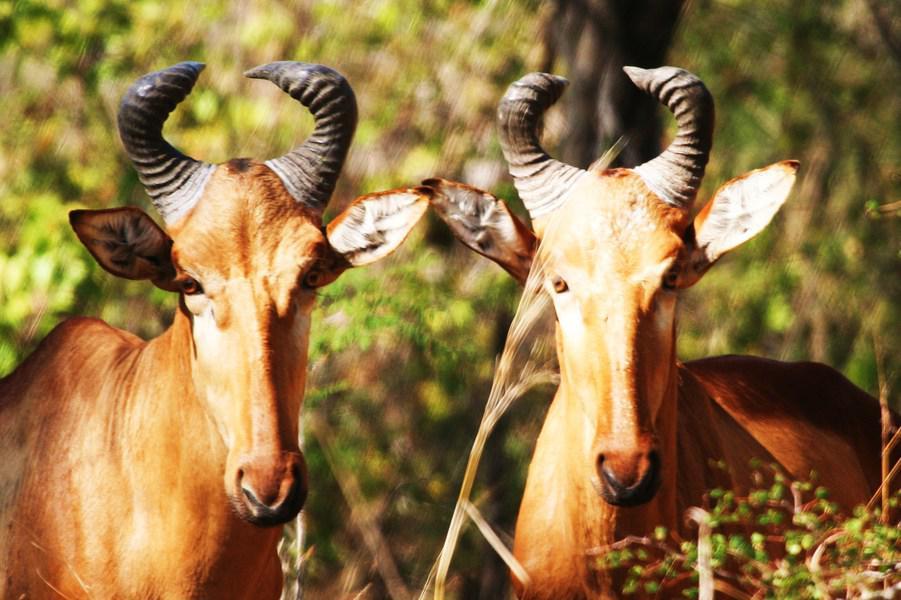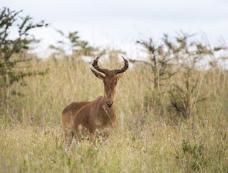The first image is the image on the left, the second image is the image on the right. For the images shown, is this caption "There is a total of two elk." true? Answer yes or no. No. The first image is the image on the left, the second image is the image on the right. For the images displayed, is the sentence "There are exactly two animals standing." factually correct? Answer yes or no. No. 